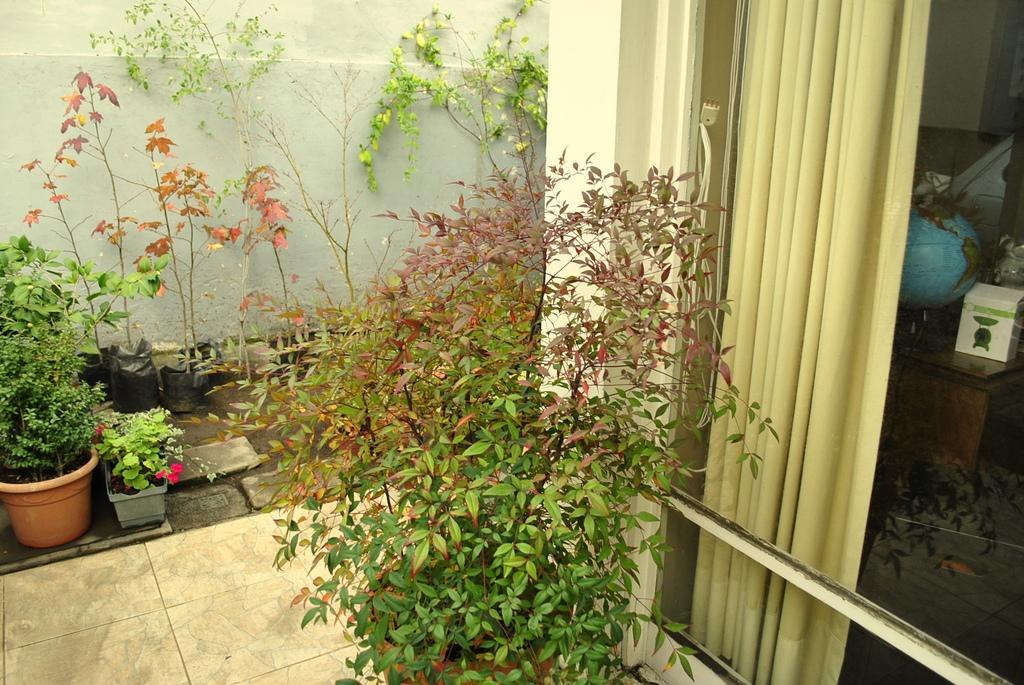What type of objects are present in the image that contain plants? There are flower pots in the image that contain plants. What type of objects are present in the image that are related to plants? There are plants in the image. What type of object is present in the image that is typically used for covering windows? There is a curtain in the image. What type of object is present in the image that represents the Earth? There is a globe in the image. What type of object is present in the image that is typically used for storing items? There is a box in the image. What type of object is present in the image that has other objects on it? There are other objects on the wooden table in the image. What type of punishment is being administered to the laborer in the image? There is no laborer or punishment present in the image. What type of scale is used to weigh the objects in the image? There is no scale present in the image. 